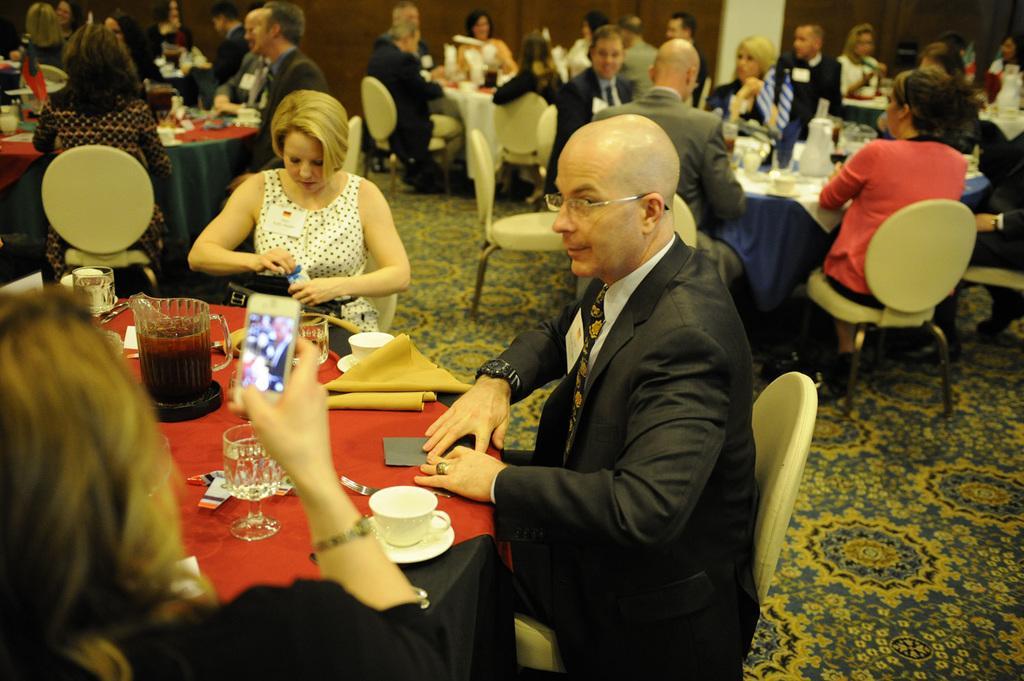Could you give a brief overview of what you see in this image? In the picture there is a table around which a man and two women sat. In the table there is a saucer, glass and a jar with a drink. In the background we can observe some tables around which some people who is sitting. 